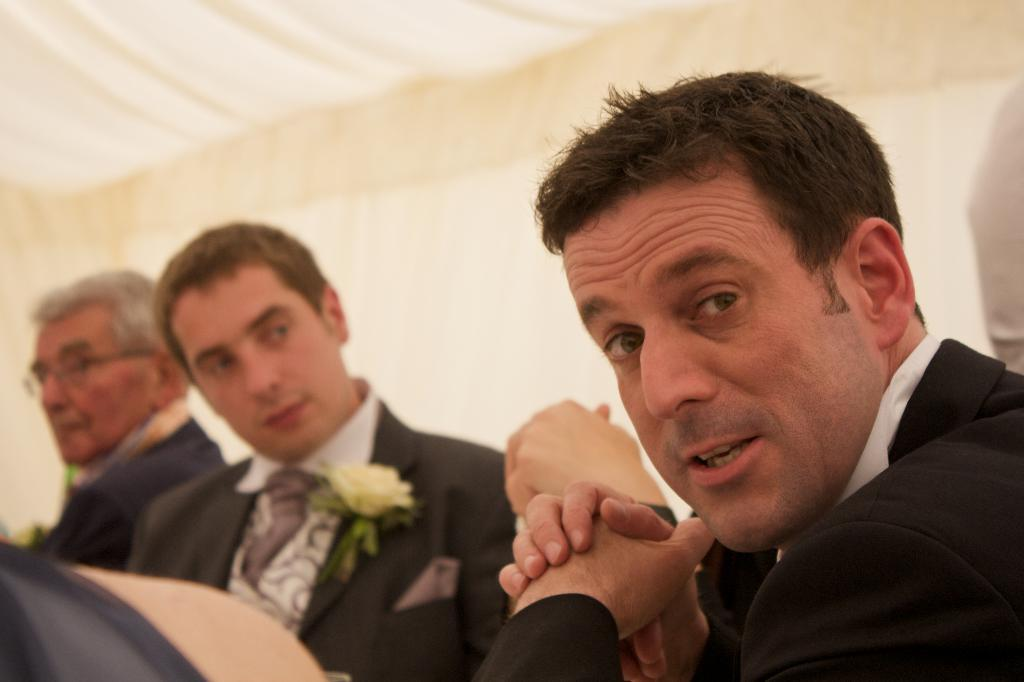How many people are present in the image? There are four persons in the image. What other objects or elements can be seen in the image? There is a flower, papers, and a wall visible in the image. Can you describe the setting or location of the image? The image may have been taken in a hall. What is the reason for the fight between the cubs in the image? There are no cubs or any indication of a fight present in the image. 